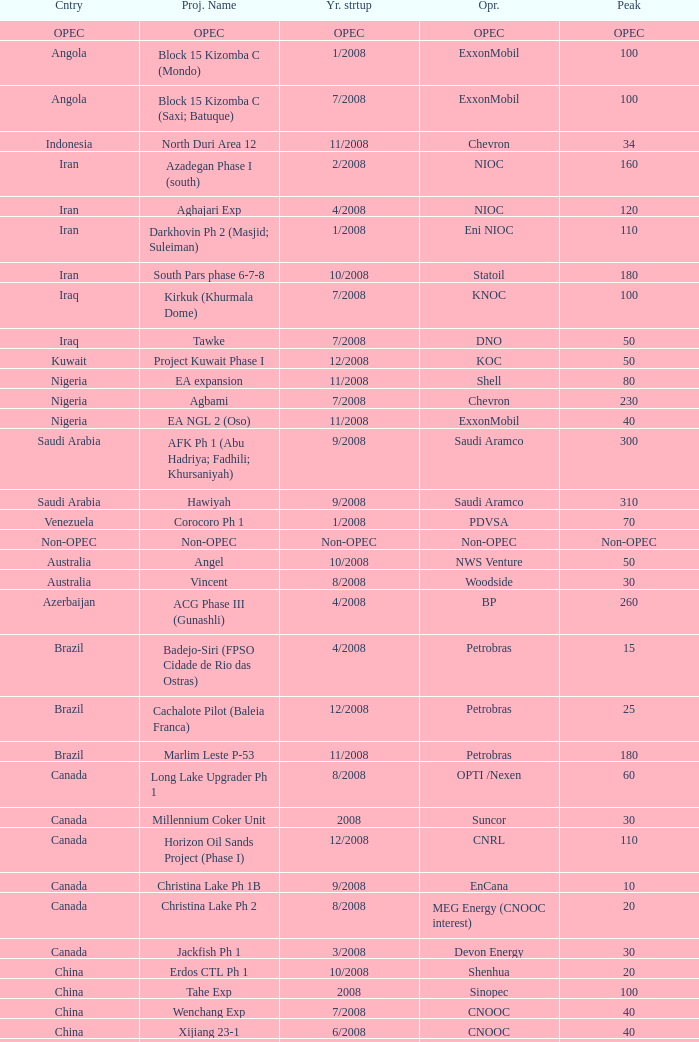What is the Project Name with a Country that is kazakhstan and a Peak that is 150? Dunga. 